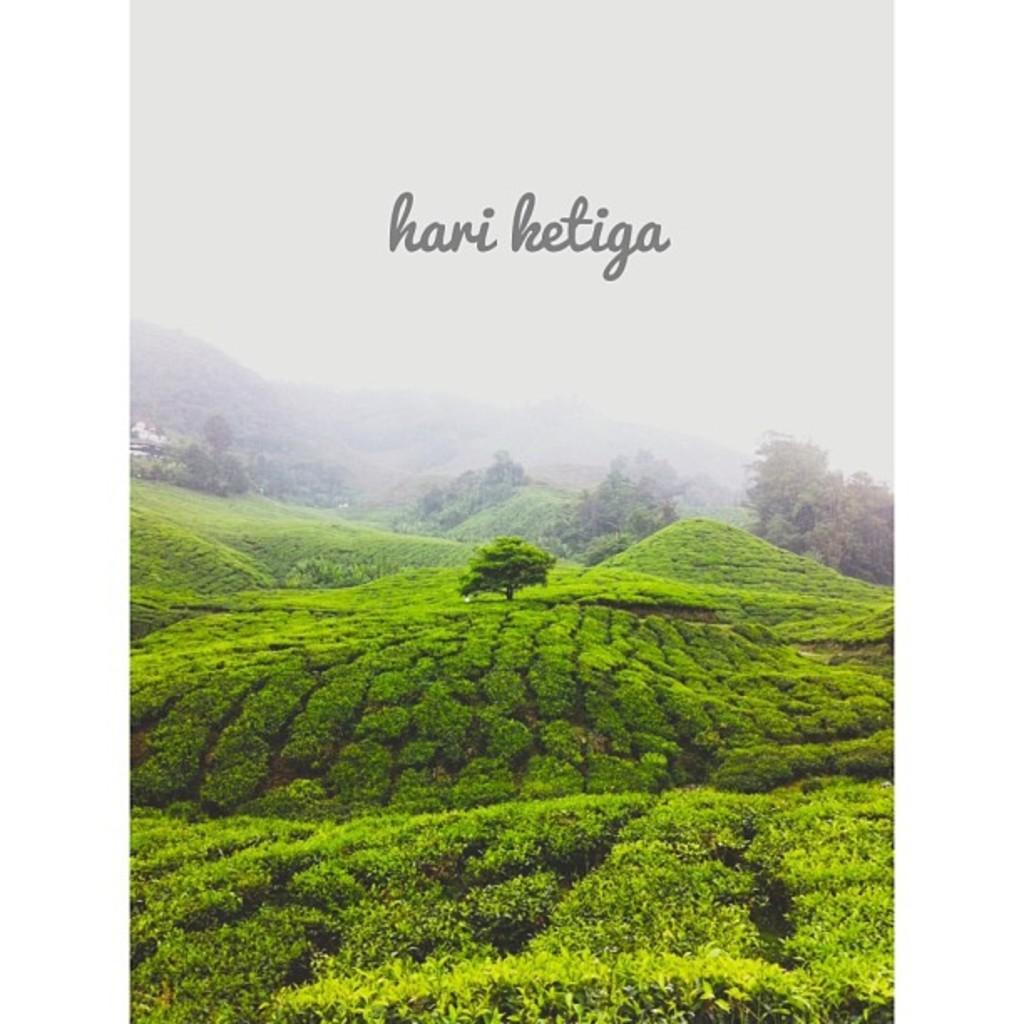Describe this image in one or two sentences. In this image there are bushes and trees, in the background of the image there are mountains and there is text at the top of the image. 